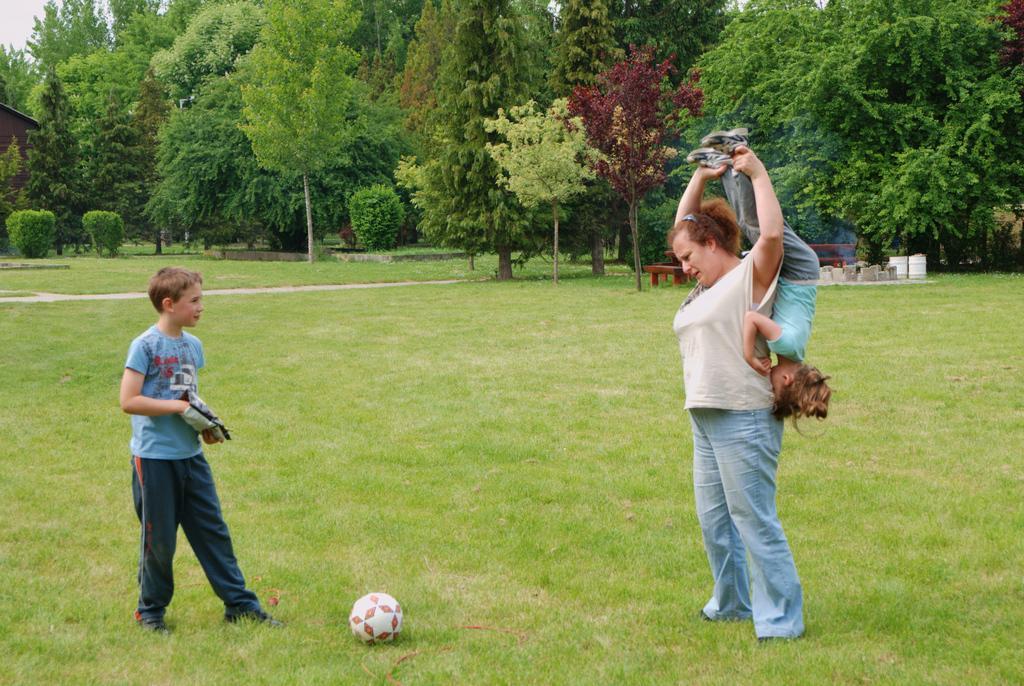In one or two sentences, can you explain what this image depicts? In the image we can see a woman and two children wearing clothes. There is even a ball on the grass. There are many trees around, we can even see there are benches, a path and a sky. 